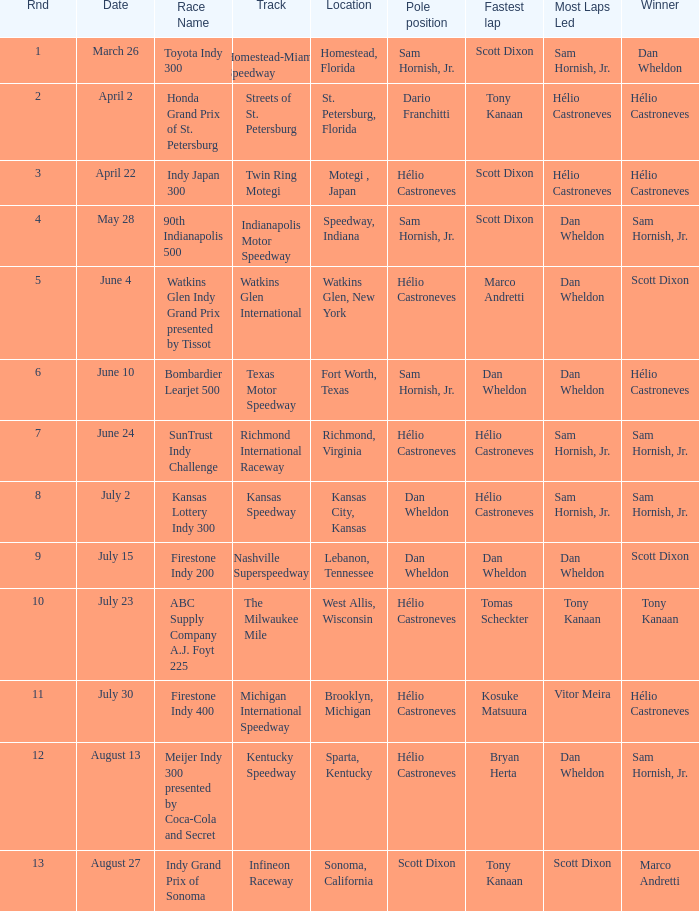How many times is the location is homestead, florida? 1.0. 